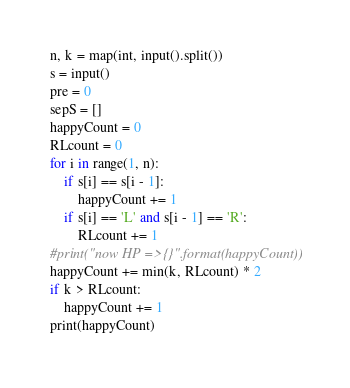<code> <loc_0><loc_0><loc_500><loc_500><_Python_>n, k = map(int, input().split())
s = input()
pre = 0
sepS = []
happyCount = 0
RLcount = 0
for i in range(1, n):
    if s[i] == s[i - 1]:
        happyCount += 1
    if s[i] == 'L' and s[i - 1] == 'R':
        RLcount += 1
#print("now HP =>{}".format(happyCount))
happyCount += min(k, RLcount) * 2
if k > RLcount:
    happyCount += 1
print(happyCount)
</code> 